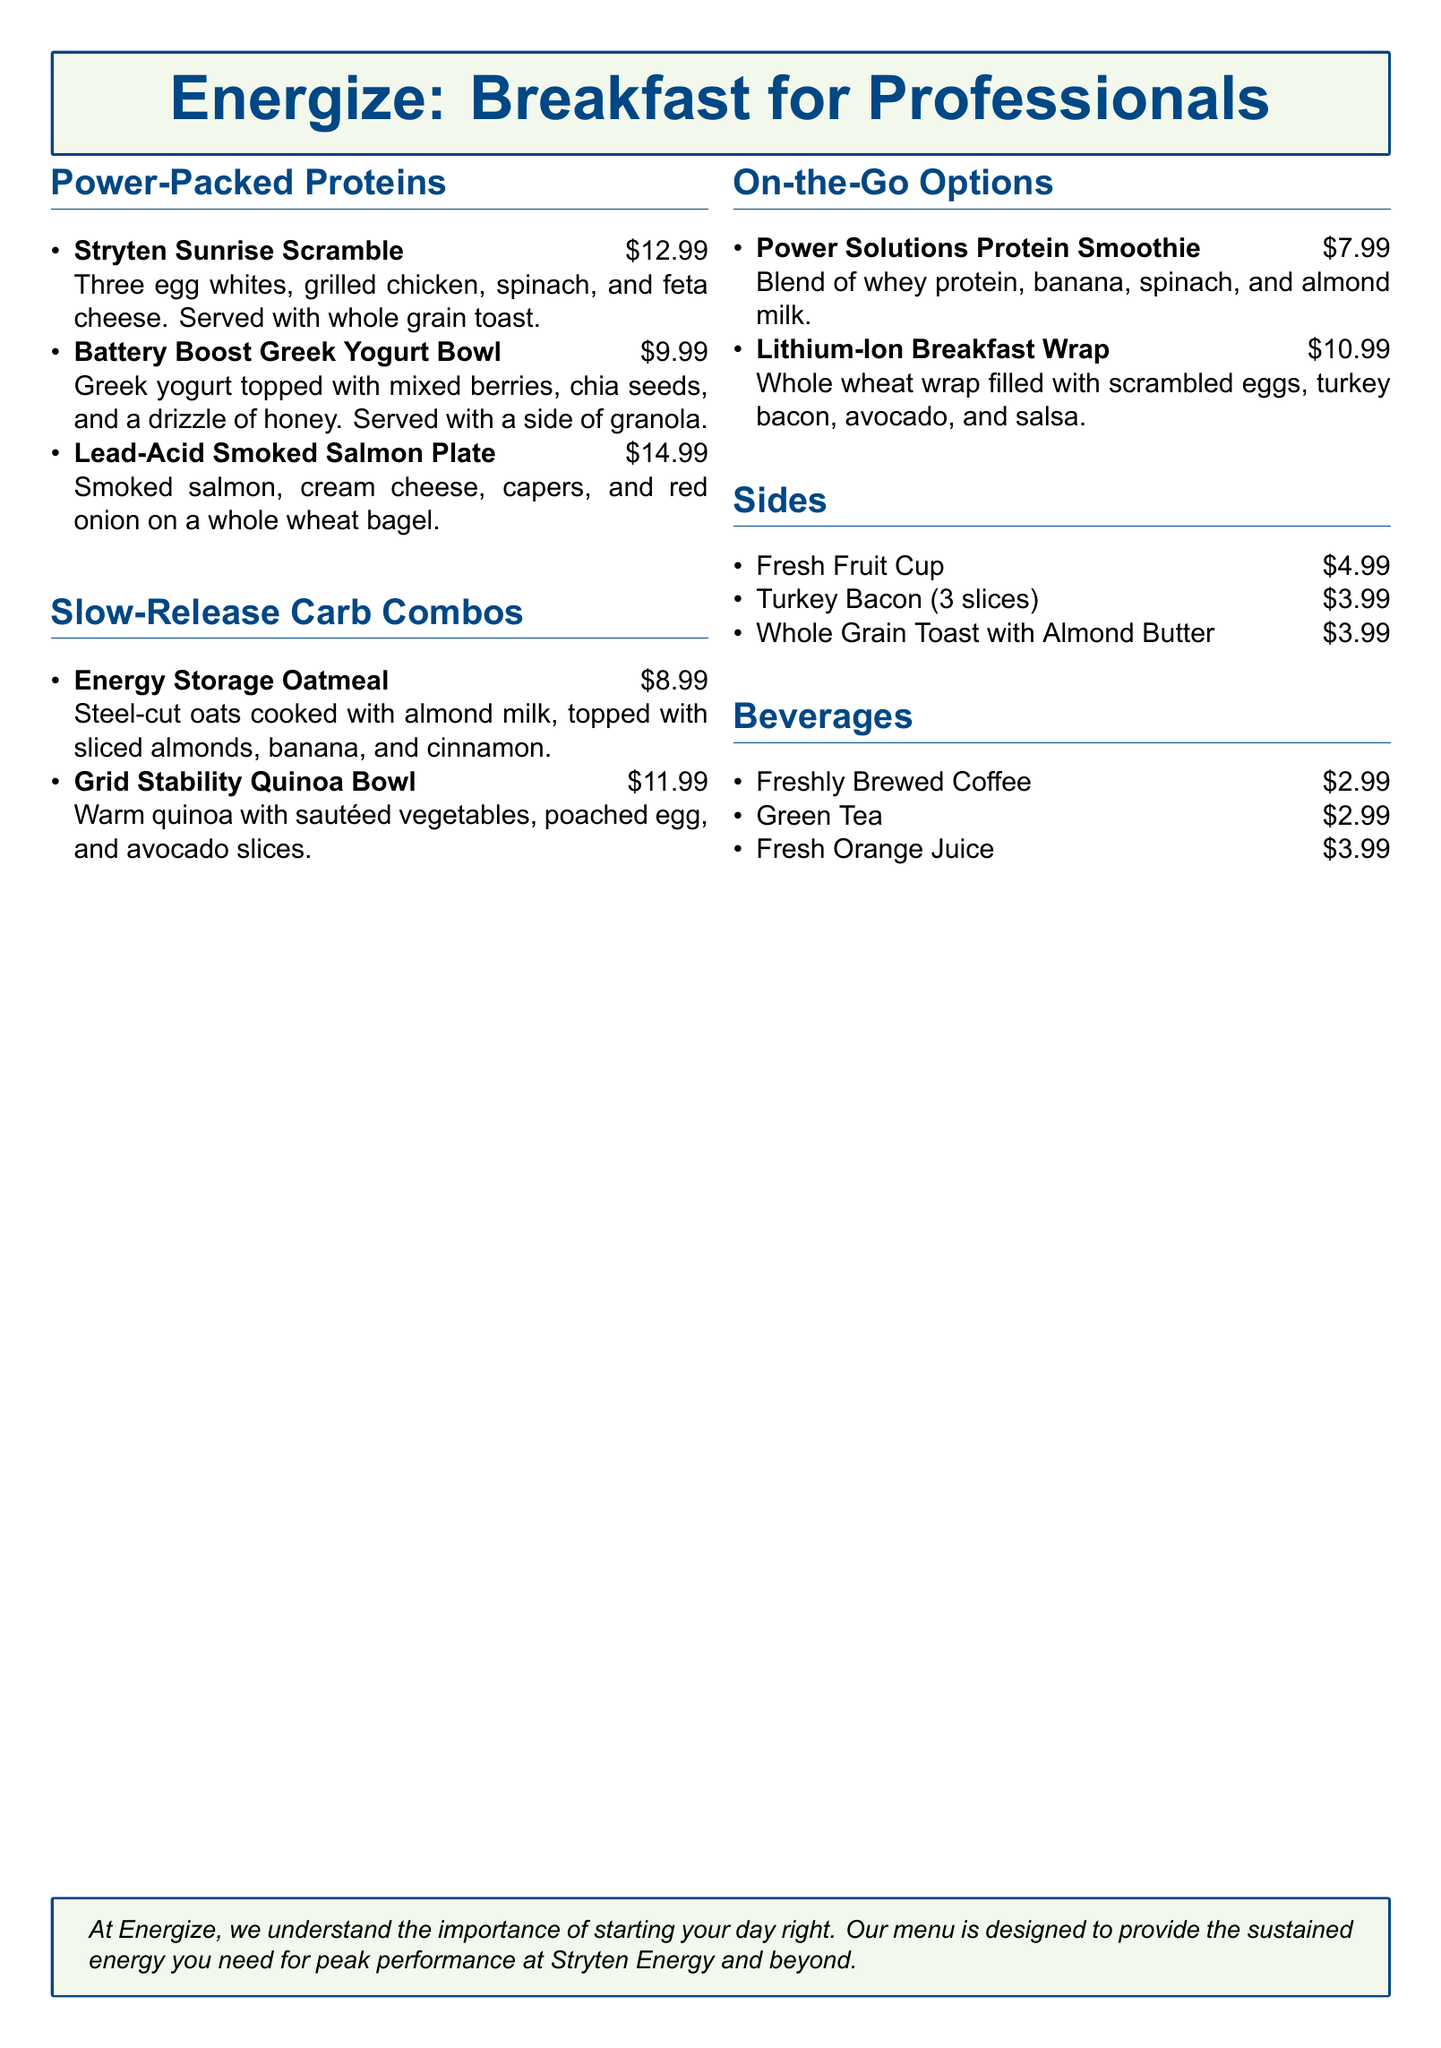What is the price of the Stryten Sunrise Scramble? The price listed for the Stryten Sunrise Scramble is $12.99.
Answer: $12.99 How many slices of turkey bacon are served as a side? The document states that 3 slices of turkey bacon are served as a side.
Answer: 3 slices What is the main protein in the Battery Boost Greek Yogurt Bowl? The main protein in the Battery Boost Greek Yogurt Bowl is Greek yogurt.
Answer: Greek yogurt Which beverage costs the most? The beverage with the highest price is Fresh Orange Juice, costing $3.99.
Answer: Fresh Orange Juice What type of oats is used in the Energy Storage Oatmeal? The document specifies that steel-cut oats are used in the Energy Storage Oatmeal.
Answer: Steel-cut oats If a customer orders all sides, what would be the total price for the Sides section? The total price for all sides is calculated as $4.99 + $3.99 + $3.99, which equals $12.97.
Answer: $12.97 What is a unique feature of the Lithium-Ion Breakfast Wrap? The unique feature of the Lithium-Ion Breakfast Wrap is that it is a whole wheat wrap.
Answer: Whole wheat wrap How many high-protein options are listed in the menu? There are three high-protein options listed under the Power-Packed Proteins section.
Answer: 3 What is the theme or focus of the breakfast menu? The theme of the breakfast menu is health-conscious and designed for busy professionals.
Answer: Health-conscious 